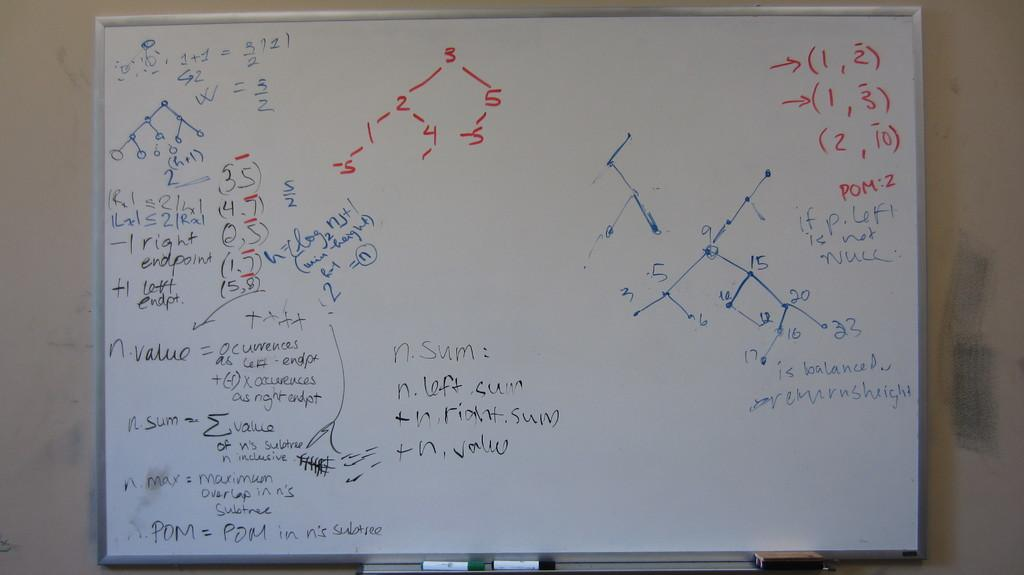<image>
Relay a brief, clear account of the picture shown. A white board has math problems and the text n. sum on it. 